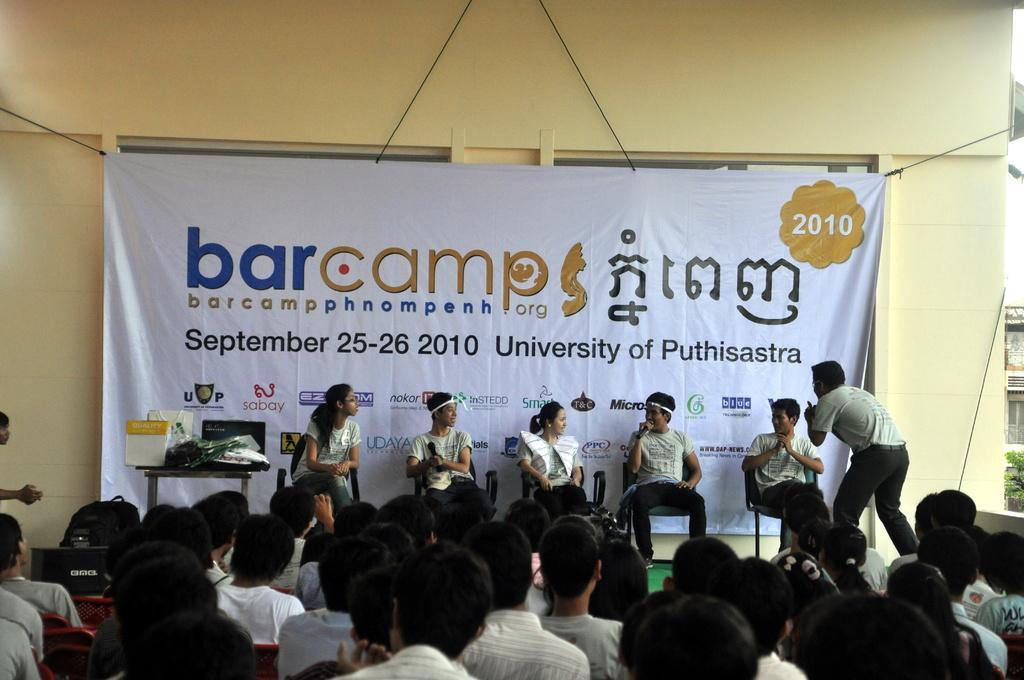Could you give a brief overview of what you see in this image? In this image at the bottom there are some people who are sitting, and in the center there are some people who are sitting on chairs and two of them are holding mikes and one person is talking something. On the left side there is one table, on the table there are some books, bags and some objects and also there is one poster and in the background there is a wall. 